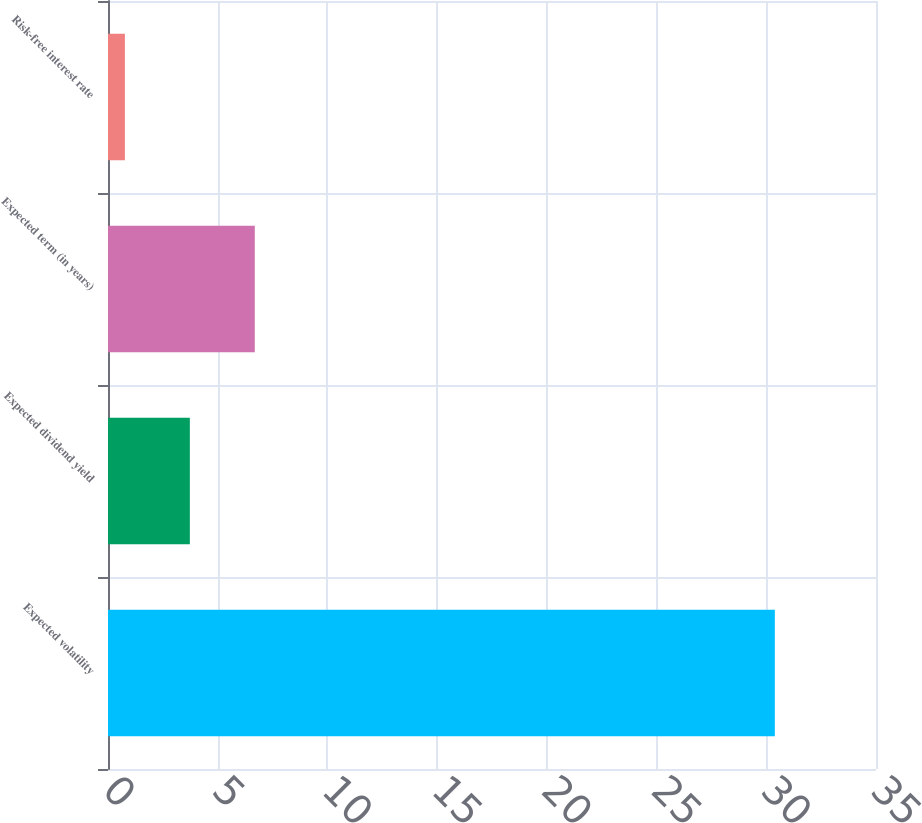<chart> <loc_0><loc_0><loc_500><loc_500><bar_chart><fcel>Expected volatility<fcel>Expected dividend yield<fcel>Expected term (in years)<fcel>Risk-free interest rate<nl><fcel>30.39<fcel>3.73<fcel>6.69<fcel>0.77<nl></chart> 